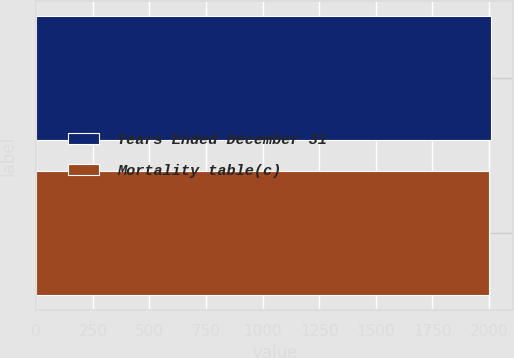Convert chart. <chart><loc_0><loc_0><loc_500><loc_500><bar_chart><fcel>Years Ended December 31<fcel>Mortality table(c)<nl><fcel>2007<fcel>2000<nl></chart> 